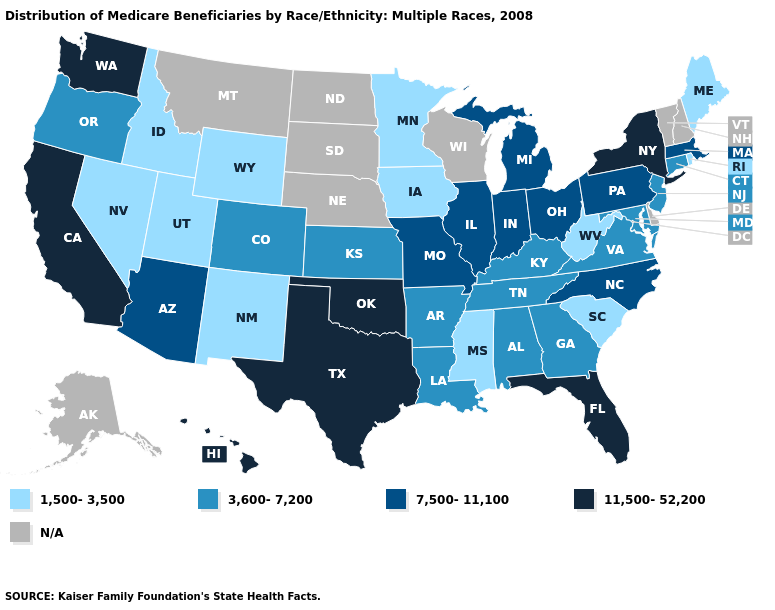Among the states that border Wyoming , which have the lowest value?
Write a very short answer. Idaho, Utah. What is the highest value in the South ?
Short answer required. 11,500-52,200. Does the map have missing data?
Keep it brief. Yes. What is the lowest value in states that border Delaware?
Keep it brief. 3,600-7,200. What is the value of West Virginia?
Short answer required. 1,500-3,500. What is the value of Minnesota?
Answer briefly. 1,500-3,500. Does the first symbol in the legend represent the smallest category?
Quick response, please. Yes. What is the value of North Carolina?
Be succinct. 7,500-11,100. Name the states that have a value in the range 7,500-11,100?
Answer briefly. Arizona, Illinois, Indiana, Massachusetts, Michigan, Missouri, North Carolina, Ohio, Pennsylvania. Does Hawaii have the highest value in the West?
Concise answer only. Yes. What is the value of California?
Short answer required. 11,500-52,200. What is the highest value in the USA?
Write a very short answer. 11,500-52,200. What is the lowest value in the Northeast?
Keep it brief. 1,500-3,500. 